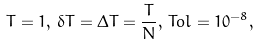<formula> <loc_0><loc_0><loc_500><loc_500>T = 1 , \, \delta T = \Delta T = \frac { T } { N } , \, T o l = 1 0 ^ { - 8 } ,</formula> 